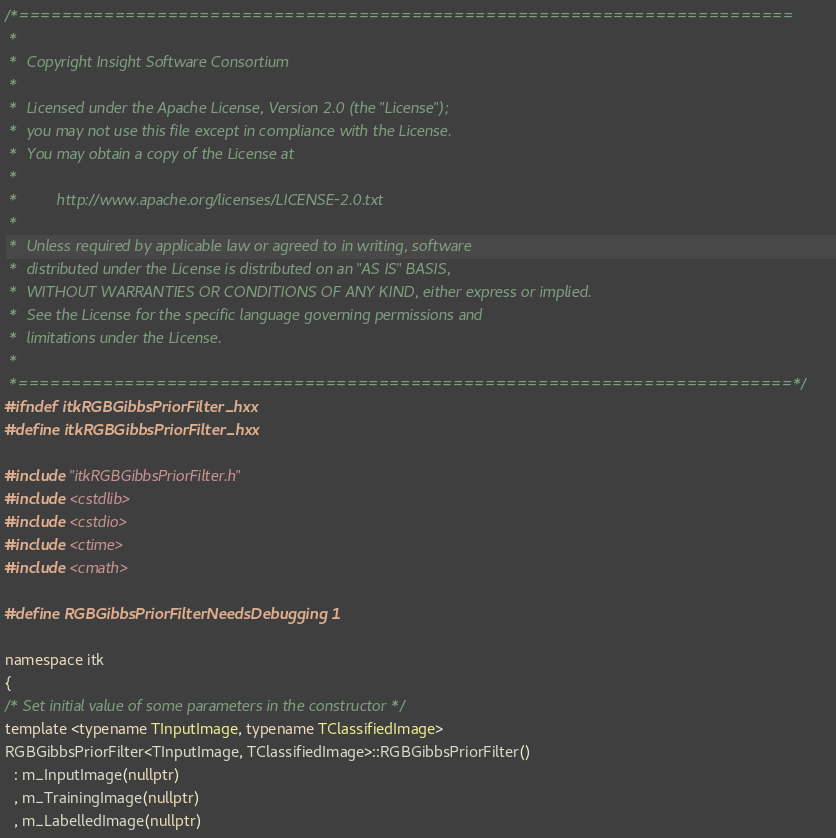<code> <loc_0><loc_0><loc_500><loc_500><_C++_>/*=========================================================================
 *
 *  Copyright Insight Software Consortium
 *
 *  Licensed under the Apache License, Version 2.0 (the "License");
 *  you may not use this file except in compliance with the License.
 *  You may obtain a copy of the License at
 *
 *         http://www.apache.org/licenses/LICENSE-2.0.txt
 *
 *  Unless required by applicable law or agreed to in writing, software
 *  distributed under the License is distributed on an "AS IS" BASIS,
 *  WITHOUT WARRANTIES OR CONDITIONS OF ANY KIND, either express or implied.
 *  See the License for the specific language governing permissions and
 *  limitations under the License.
 *
 *=========================================================================*/
#ifndef itkRGBGibbsPriorFilter_hxx
#define itkRGBGibbsPriorFilter_hxx

#include "itkRGBGibbsPriorFilter.h"
#include <cstdlib>
#include <cstdio>
#include <ctime>
#include <cmath>

#define RGBGibbsPriorFilterNeedsDebugging 1

namespace itk
{
/* Set initial value of some parameters in the constructor */
template <typename TInputImage, typename TClassifiedImage>
RGBGibbsPriorFilter<TInputImage, TClassifiedImage>::RGBGibbsPriorFilter()
  : m_InputImage(nullptr)
  , m_TrainingImage(nullptr)
  , m_LabelledImage(nullptr)</code> 